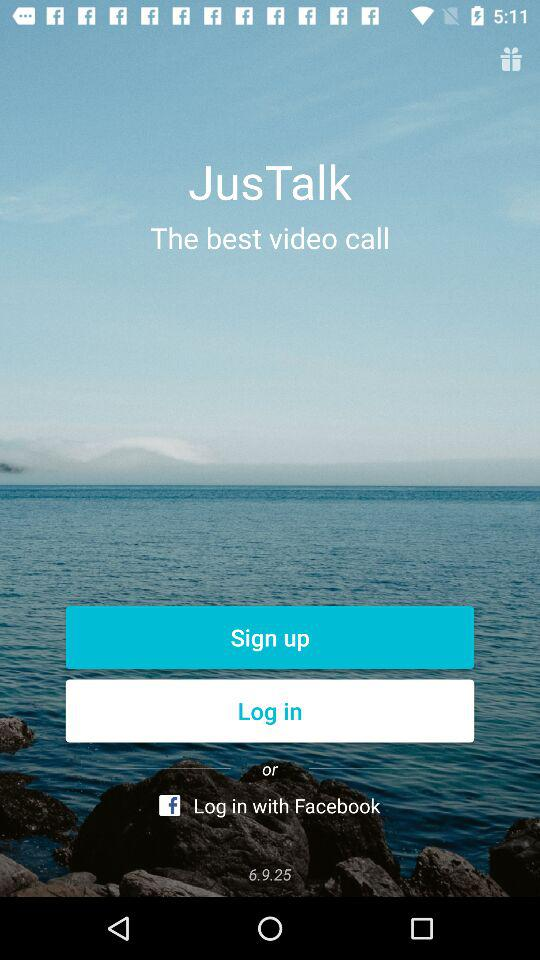When was the current version of "JusTalk" updated?
When the provided information is insufficient, respond with <no answer>. <no answer> 